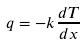<formula> <loc_0><loc_0><loc_500><loc_500>q = - k \frac { d T } { d x }</formula> 